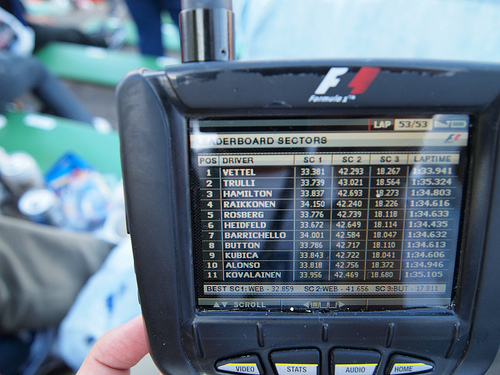<image>
Is the screen next to the person? Yes. The screen is positioned adjacent to the person, located nearby in the same general area. 